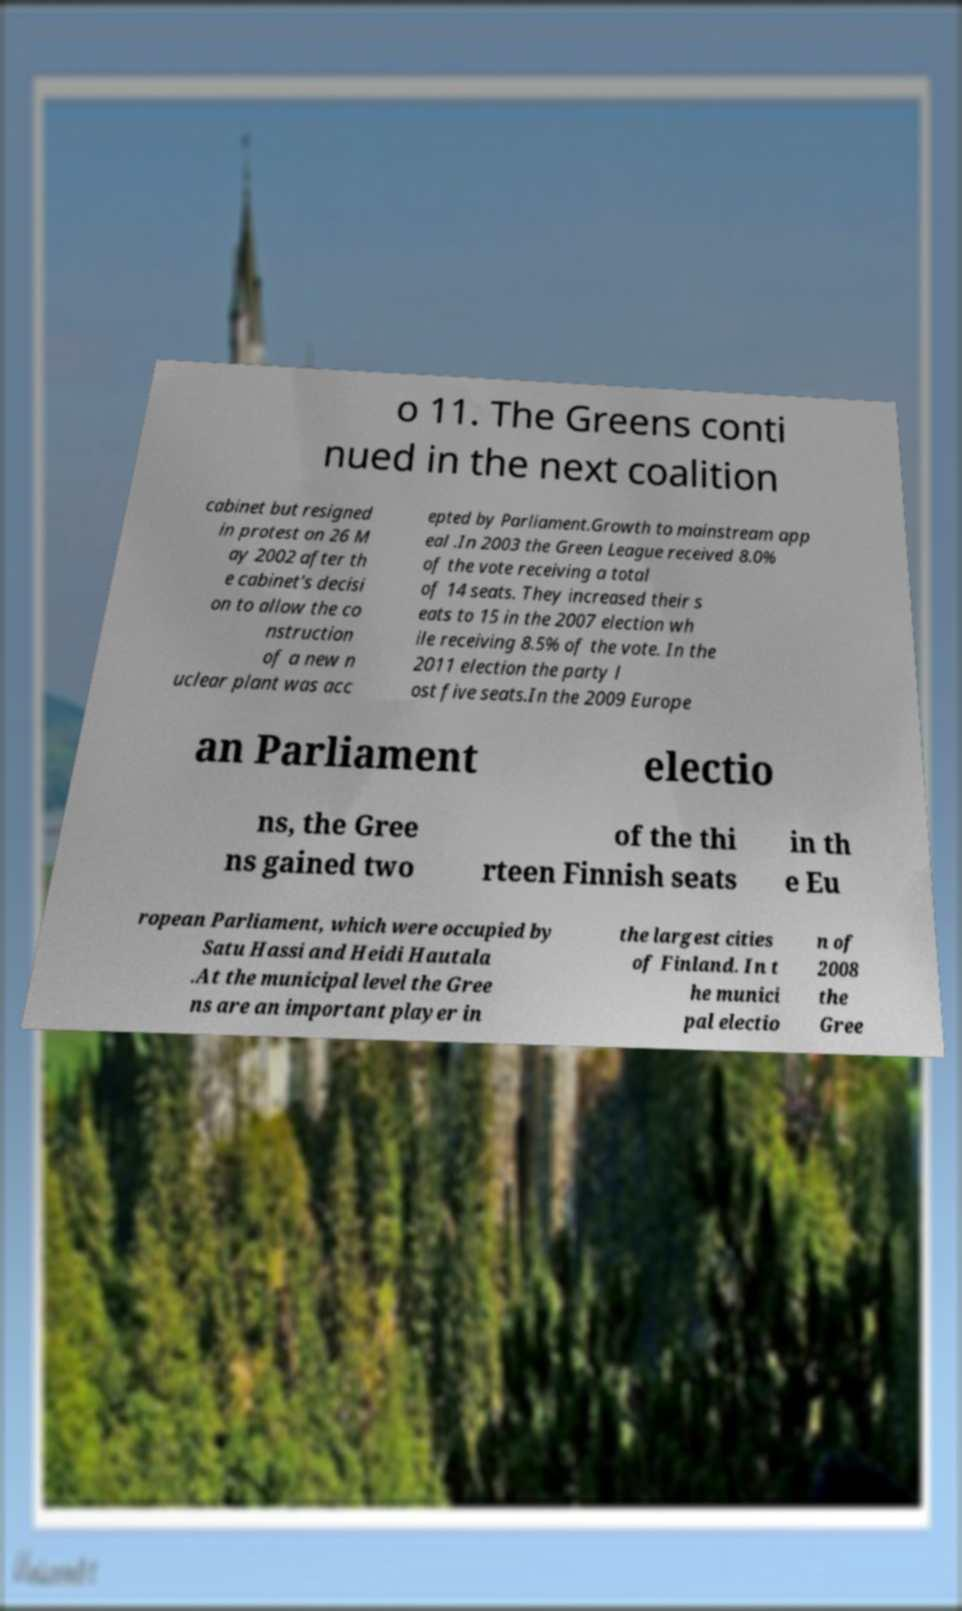Could you assist in decoding the text presented in this image and type it out clearly? o 11. The Greens conti nued in the next coalition cabinet but resigned in protest on 26 M ay 2002 after th e cabinet's decisi on to allow the co nstruction of a new n uclear plant was acc epted by Parliament.Growth to mainstream app eal .In 2003 the Green League received 8.0% of the vote receiving a total of 14 seats. They increased their s eats to 15 in the 2007 election wh ile receiving 8.5% of the vote. In the 2011 election the party l ost five seats.In the 2009 Europe an Parliament electio ns, the Gree ns gained two of the thi rteen Finnish seats in th e Eu ropean Parliament, which were occupied by Satu Hassi and Heidi Hautala .At the municipal level the Gree ns are an important player in the largest cities of Finland. In t he munici pal electio n of 2008 the Gree 